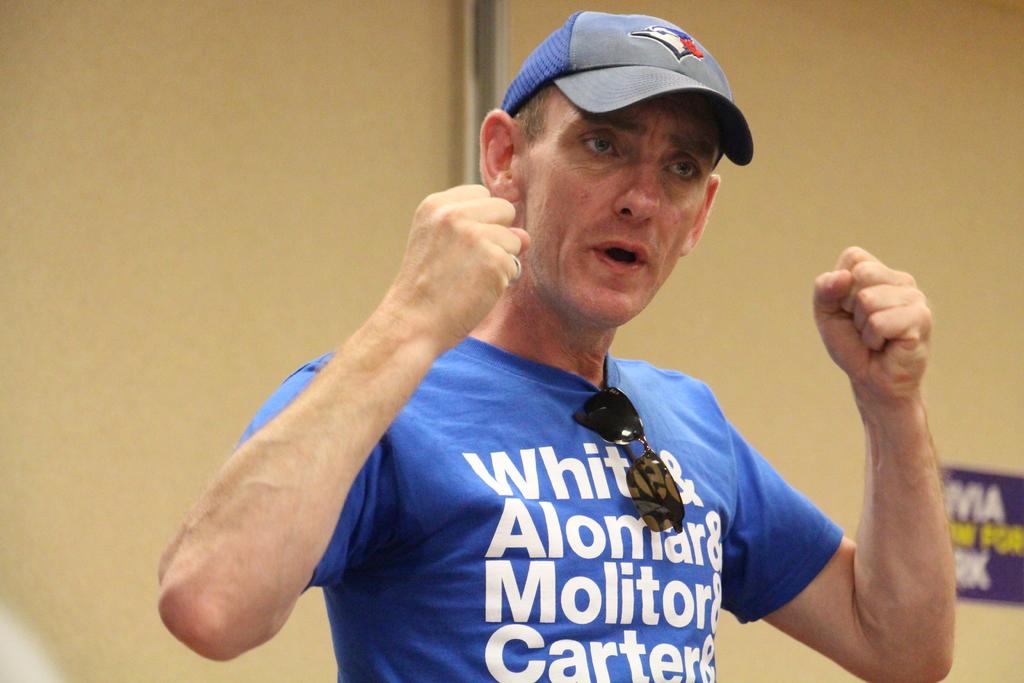What does the first word of this mans shirt read?
Keep it short and to the point. White. 